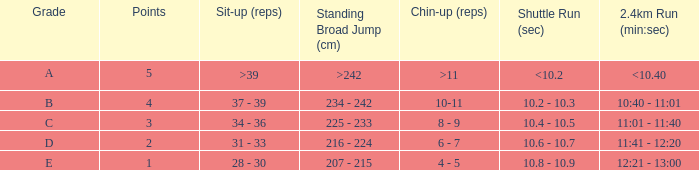How many points are earned for completing a 2.4km run in under 2 minutes? 12:21 - 13:00. 